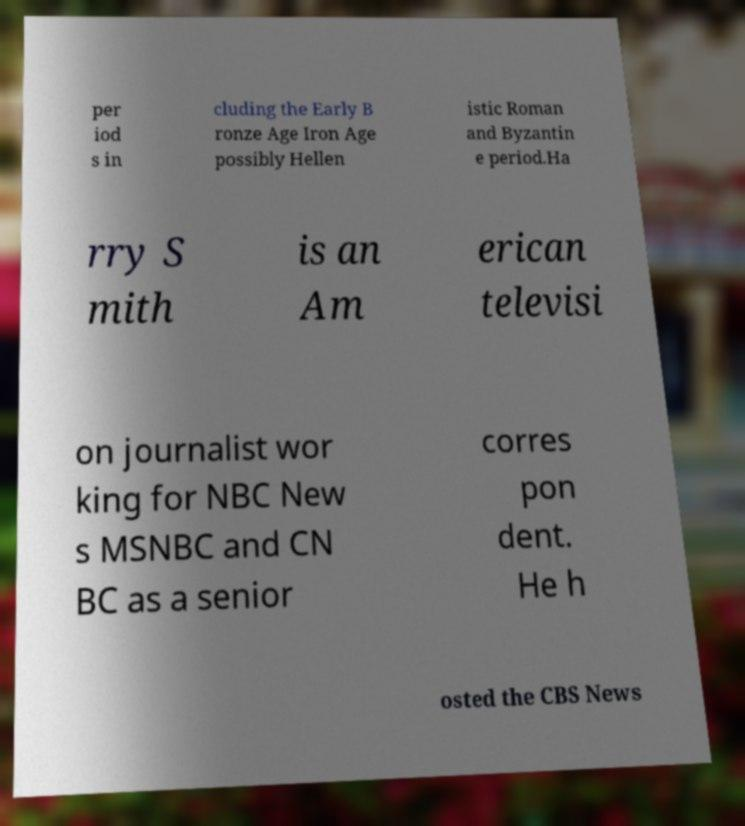For documentation purposes, I need the text within this image transcribed. Could you provide that? per iod s in cluding the Early B ronze Age Iron Age possibly Hellen istic Roman and Byzantin e period.Ha rry S mith is an Am erican televisi on journalist wor king for NBC New s MSNBC and CN BC as a senior corres pon dent. He h osted the CBS News 